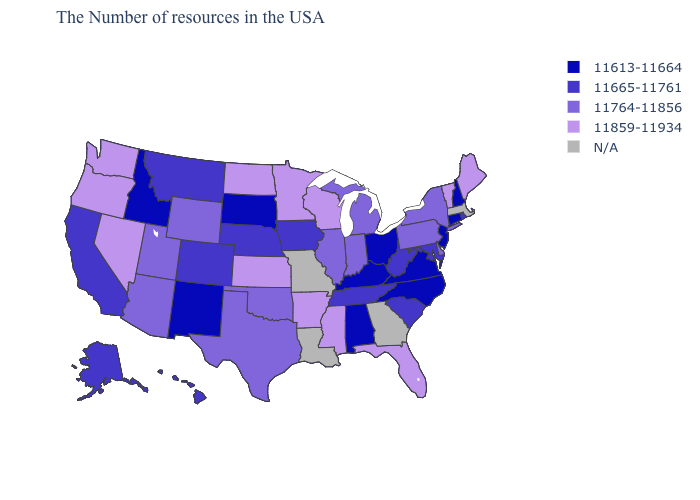Among the states that border Ohio , which have the highest value?
Write a very short answer. Pennsylvania, Michigan, Indiana. What is the value of Utah?
Be succinct. 11764-11856. How many symbols are there in the legend?
Give a very brief answer. 5. What is the lowest value in the USA?
Write a very short answer. 11613-11664. Name the states that have a value in the range 11859-11934?
Short answer required. Maine, Vermont, Florida, Wisconsin, Mississippi, Arkansas, Minnesota, Kansas, North Dakota, Nevada, Washington, Oregon. Does Colorado have the lowest value in the West?
Keep it brief. No. What is the value of New Mexico?
Quick response, please. 11613-11664. What is the highest value in the South ?
Give a very brief answer. 11859-11934. What is the value of Rhode Island?
Short answer required. 11665-11761. Which states have the lowest value in the South?
Concise answer only. Virginia, North Carolina, Kentucky, Alabama. What is the value of California?
Give a very brief answer. 11665-11761. What is the highest value in the Northeast ?
Write a very short answer. 11859-11934. Name the states that have a value in the range 11613-11664?
Short answer required. New Hampshire, Connecticut, New Jersey, Virginia, North Carolina, Ohio, Kentucky, Alabama, South Dakota, New Mexico, Idaho. Which states hav the highest value in the West?
Quick response, please. Nevada, Washington, Oregon. 